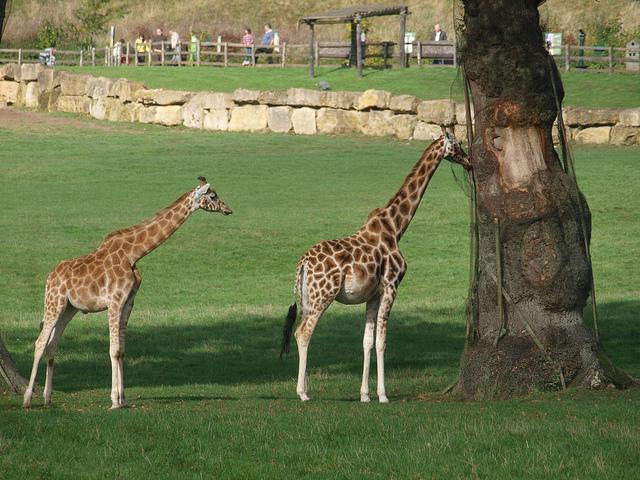How many giraffes are there?
Give a very brief answer. 2. 